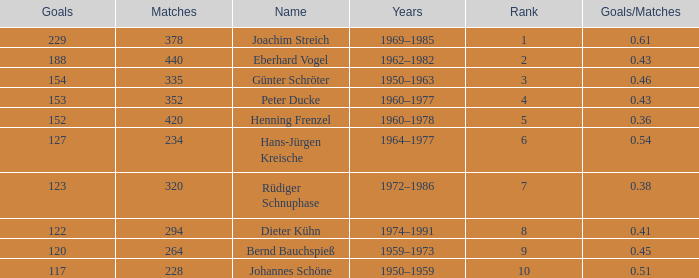Would you mind parsing the complete table? {'header': ['Goals', 'Matches', 'Name', 'Years', 'Rank', 'Goals/Matches'], 'rows': [['229', '378', 'Joachim Streich', '1969–1985', '1', '0.61'], ['188', '440', 'Eberhard Vogel', '1962–1982', '2', '0.43'], ['154', '335', 'Günter Schröter', '1950–1963', '3', '0.46'], ['153', '352', 'Peter Ducke', '1960–1977', '4', '0.43'], ['152', '420', 'Henning Frenzel', '1960–1978', '5', '0.36'], ['127', '234', 'Hans-Jürgen Kreische', '1964–1977', '6', '0.54'], ['123', '320', 'Rüdiger Schnuphase', '1972–1986', '7', '0.38'], ['122', '294', 'Dieter Kühn', '1974–1991', '8', '0.41'], ['120', '264', 'Bernd Bauchspieß', '1959–1973', '9', '0.45'], ['117', '228', 'Johannes Schöne', '1950–1959', '10', '0.51']]} How many goals/matches have 153 as the goals with matches greater than 352? None. 